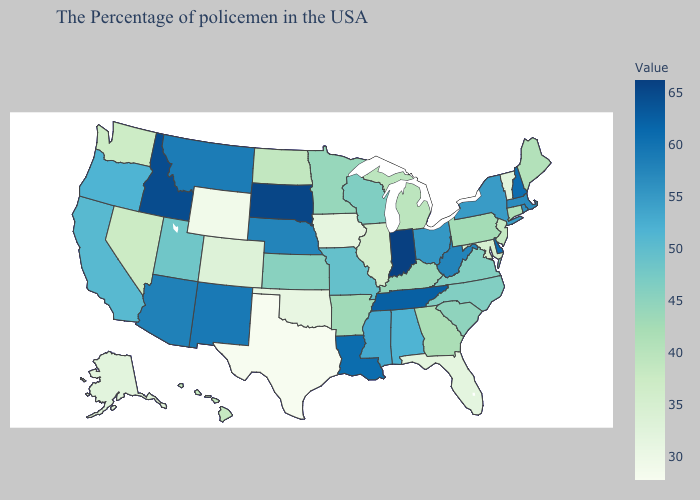Among the states that border Wyoming , does Montana have the highest value?
Be succinct. No. Which states hav the highest value in the Northeast?
Give a very brief answer. New Hampshire. Which states have the highest value in the USA?
Concise answer only. Indiana. Which states have the lowest value in the USA?
Concise answer only. Texas. Does Hawaii have the highest value in the West?
Short answer required. No. 